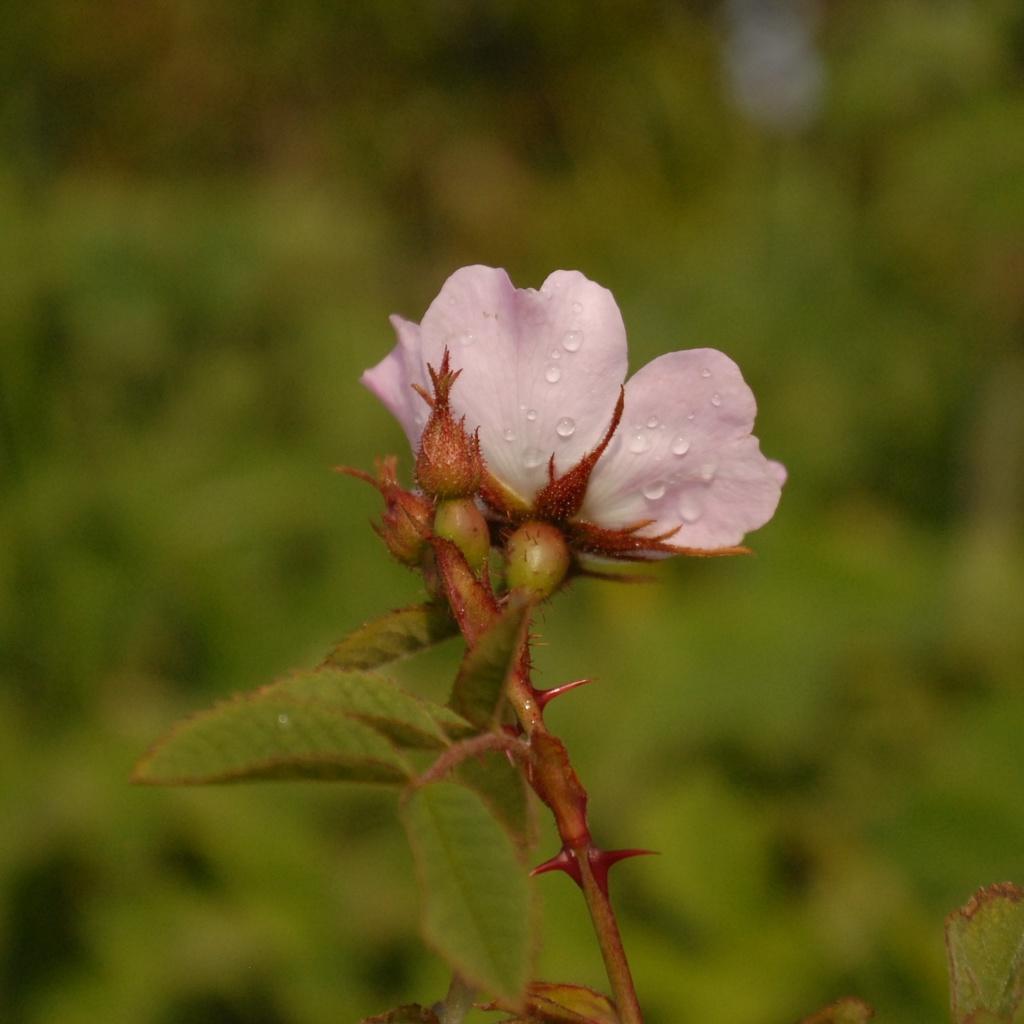Could you give a brief overview of what you see in this image? In this picture we can see a flower and plant. In the background of the image it is blue and green. 